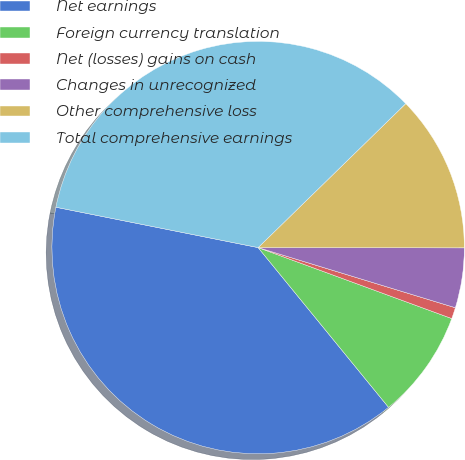Convert chart to OTSL. <chart><loc_0><loc_0><loc_500><loc_500><pie_chart><fcel>Net earnings<fcel>Foreign currency translation<fcel>Net (losses) gains on cash<fcel>Changes in unrecognized<fcel>Other comprehensive loss<fcel>Total comprehensive earnings<nl><fcel>39.03%<fcel>8.51%<fcel>0.88%<fcel>4.69%<fcel>12.32%<fcel>34.56%<nl></chart> 